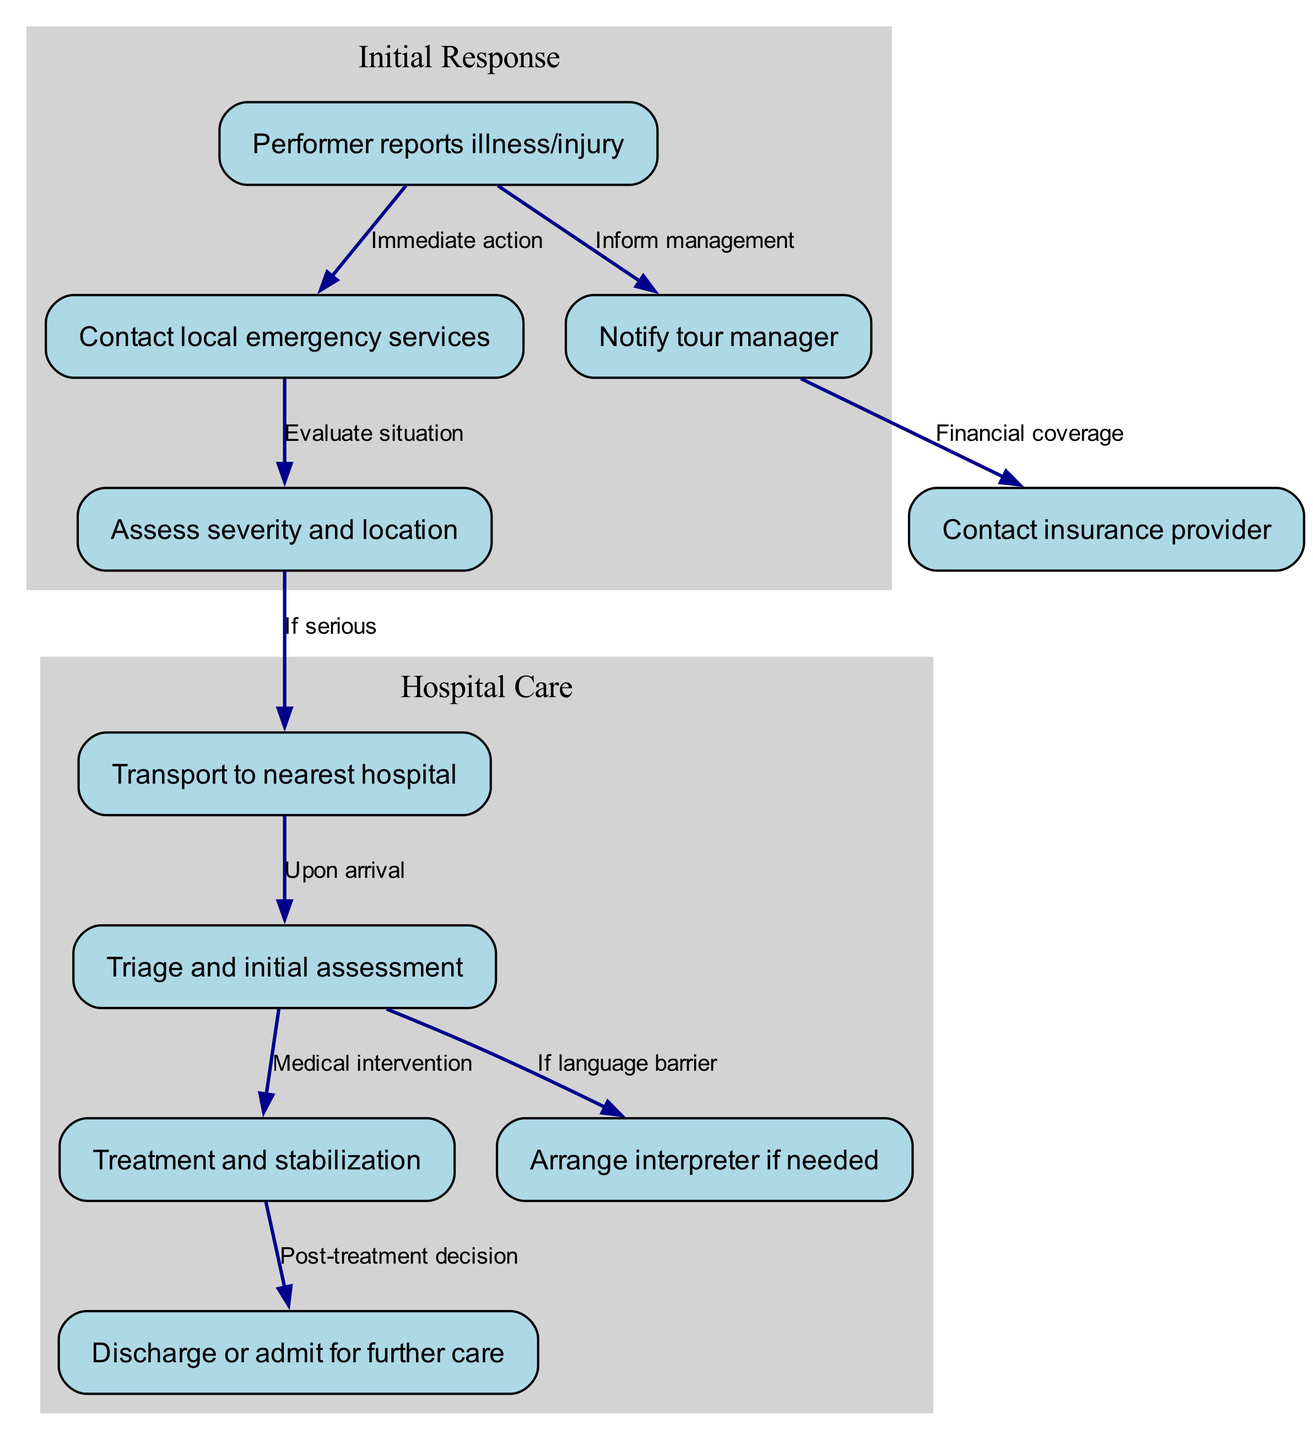What is the first step when a performer reports an illness or injury? The first step indicated in the diagram is to contact local emergency services. This is shown directly connected to the node representing the performer's report of illness or injury, indicating immediate action must be taken.
Answer: Contact local emergency services How many nodes are there in total? The diagram consists of ten nodes, which represent various stages in the emergency medical care process. Each node is categorized as a specific action or decision point in the pathway.
Answer: Ten Which node involves informing management? Informing management is depicted in the diagram as a connection from the performer’s report of illness or injury to the node labeled "Notify tour manager." This shows it as a part of the process.
Answer: Notify tour manager What happens after contacting local emergency services? After contacting local emergency services, the next step is to assess the severity and location of the illness or injury. This progression is clearly indicated through the connected arrows in the diagram.
Answer: Assess severity and location If language is a barrier, what is arranged? If there’s a language barrier, the diagram shows that an interpreter should be arranged. This aligns with the point where medical teams may require assistance in communication, as indicated by the connection from the triage and initial assessment node.
Answer: Arrange interpreter if needed What is the connection between treatment and post-treatment decision? The connection between treatment and post-treatment decision is established through the node labeled "Treatment and stabilization" leading to "Discharge or admit for further care." This indicates that the treatment outcome directly impacts the next step in the process.
Answer: Treatment and stabilization to Discharge or admit for further care What is needed from the tour manager during the process? The tour manager is needed to contact the insurance provider for financial coverage. This is depicted in the diagram as a necessary action to ensure medical expenses are taken care of.
Answer: Contact insurance provider What is evaluated after the performer reports an illness or injury? After the performer reports the issue, the situation is evaluated. This is explicitly illustrated as the next step in the pathway following the report of illness or injury.
Answer: Evaluate situation What leads to the transport to the nearest hospital? The decision to transport to the nearest hospital is made if the severity of the illness or injury is serious, as indicated by the connection between "Assess severity and location" and "Transport to nearest hospital."
Answer: If serious 